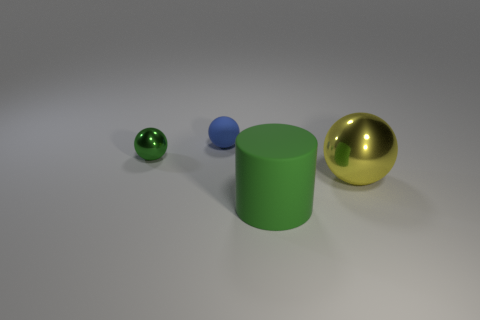What material is the thing that is in front of the large yellow metal sphere?
Your response must be concise. Rubber. What size is the matte object that is the same shape as the green shiny thing?
Keep it short and to the point. Small. Are there fewer green spheres that are right of the green rubber thing than small blue objects?
Give a very brief answer. Yes. Are any small blue shiny cylinders visible?
Keep it short and to the point. No. The other matte thing that is the same shape as the big yellow thing is what color?
Keep it short and to the point. Blue. Do the rubber object to the right of the matte ball and the small metal ball have the same color?
Make the answer very short. Yes. Does the green metallic sphere have the same size as the yellow thing?
Provide a short and direct response. No. What is the shape of the tiny blue thing that is made of the same material as the large green object?
Provide a succinct answer. Sphere. What number of other things are there of the same shape as the big matte thing?
Offer a terse response. 0. What is the shape of the green object right of the rubber thing that is behind the green thing that is in front of the yellow metal sphere?
Ensure brevity in your answer.  Cylinder. 